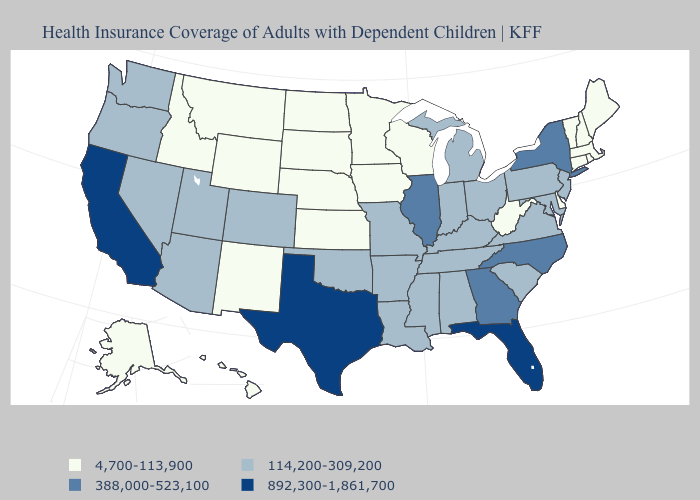Does New Hampshire have the lowest value in the USA?
Answer briefly. Yes. Which states have the lowest value in the USA?
Give a very brief answer. Alaska, Connecticut, Delaware, Hawaii, Idaho, Iowa, Kansas, Maine, Massachusetts, Minnesota, Montana, Nebraska, New Hampshire, New Mexico, North Dakota, Rhode Island, South Dakota, Vermont, West Virginia, Wisconsin, Wyoming. Name the states that have a value in the range 114,200-309,200?
Concise answer only. Alabama, Arizona, Arkansas, Colorado, Indiana, Kentucky, Louisiana, Maryland, Michigan, Mississippi, Missouri, Nevada, New Jersey, Ohio, Oklahoma, Oregon, Pennsylvania, South Carolina, Tennessee, Utah, Virginia, Washington. What is the lowest value in states that border New Jersey?
Give a very brief answer. 4,700-113,900. Name the states that have a value in the range 4,700-113,900?
Write a very short answer. Alaska, Connecticut, Delaware, Hawaii, Idaho, Iowa, Kansas, Maine, Massachusetts, Minnesota, Montana, Nebraska, New Hampshire, New Mexico, North Dakota, Rhode Island, South Dakota, Vermont, West Virginia, Wisconsin, Wyoming. Does Mississippi have a higher value than South Dakota?
Short answer required. Yes. What is the lowest value in the USA?
Be succinct. 4,700-113,900. Name the states that have a value in the range 388,000-523,100?
Be succinct. Georgia, Illinois, New York, North Carolina. Name the states that have a value in the range 114,200-309,200?
Give a very brief answer. Alabama, Arizona, Arkansas, Colorado, Indiana, Kentucky, Louisiana, Maryland, Michigan, Mississippi, Missouri, Nevada, New Jersey, Ohio, Oklahoma, Oregon, Pennsylvania, South Carolina, Tennessee, Utah, Virginia, Washington. Does the first symbol in the legend represent the smallest category?
Keep it brief. Yes. Does Virginia have the lowest value in the USA?
Quick response, please. No. Name the states that have a value in the range 4,700-113,900?
Quick response, please. Alaska, Connecticut, Delaware, Hawaii, Idaho, Iowa, Kansas, Maine, Massachusetts, Minnesota, Montana, Nebraska, New Hampshire, New Mexico, North Dakota, Rhode Island, South Dakota, Vermont, West Virginia, Wisconsin, Wyoming. Does Florida have the same value as California?
Keep it brief. Yes. Name the states that have a value in the range 388,000-523,100?
Write a very short answer. Georgia, Illinois, New York, North Carolina. 